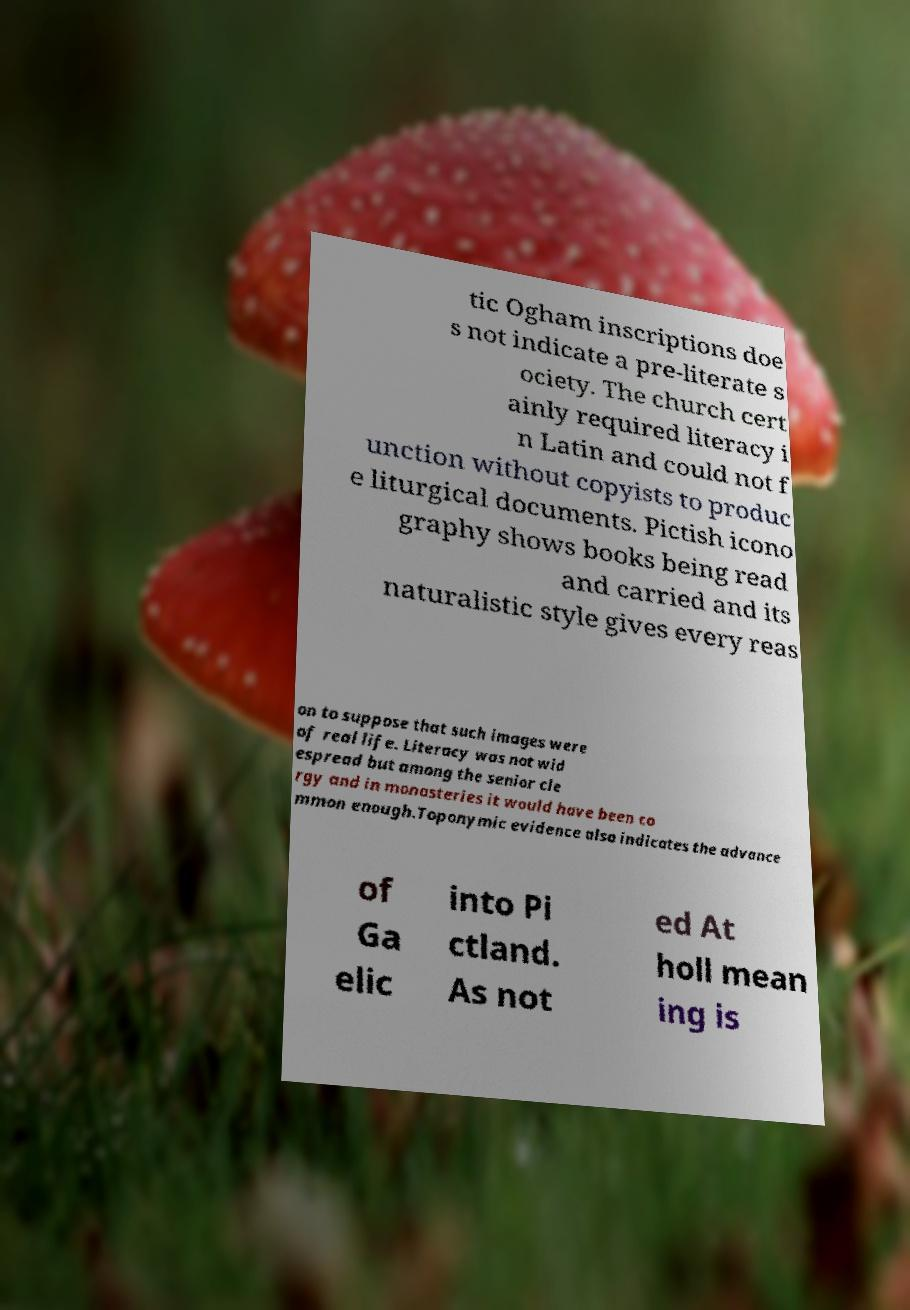Can you read and provide the text displayed in the image?This photo seems to have some interesting text. Can you extract and type it out for me? tic Ogham inscriptions doe s not indicate a pre-literate s ociety. The church cert ainly required literacy i n Latin and could not f unction without copyists to produc e liturgical documents. Pictish icono graphy shows books being read and carried and its naturalistic style gives every reas on to suppose that such images were of real life. Literacy was not wid espread but among the senior cle rgy and in monasteries it would have been co mmon enough.Toponymic evidence also indicates the advance of Ga elic into Pi ctland. As not ed At holl mean ing is 